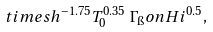Convert formula to latex. <formula><loc_0><loc_0><loc_500><loc_500>\quad t i m e s h ^ { - 1 . 7 5 } T _ { 0 } ^ { 0 . 3 5 } \, \Gamma _ { \i } o n { H } { i } ^ { 0 . 5 } ,</formula> 